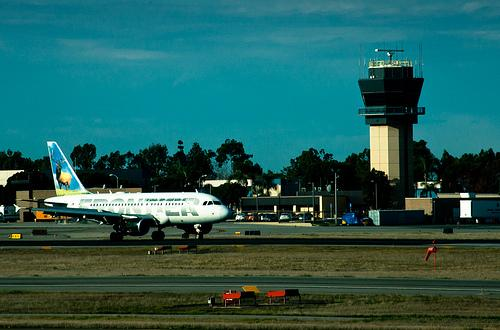Describe the feeling or mood this image conveys. The image conveys a calm and organized mood typical of an airport scene with a clear day and well-maintained facilities. What is the most striking feature of the airplane in the image? The most striking feature of the airplane is the elk painted on the tail wing. Provide a brief description of the setting and primary focus of the image. The image shows an airport setting with a runway, airport control tower, and a Frontier Airlines plane with an elk painted on its tail wing, parked on the tarmac. How many cars are parked in the parking lot in the image? There is a row of parked cars, but the exact number of cars is not specified in the information provided. Identify three distinct objects or elements in the background of the image. Three distinct background elements in the image are cloudless sky, row of trees, and runway buildings. How many airplanes can you see in the picture and what is happening with the main plane? There is one airplane visible in the picture, the main plane is parked on the tarmac at an airport. 